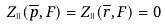Convert formula to latex. <formula><loc_0><loc_0><loc_500><loc_500>Z _ { \shortparallel } ( \overline { p } , F ) = Z _ { \shortparallel } ( \overline { r } , F ) = 0</formula> 